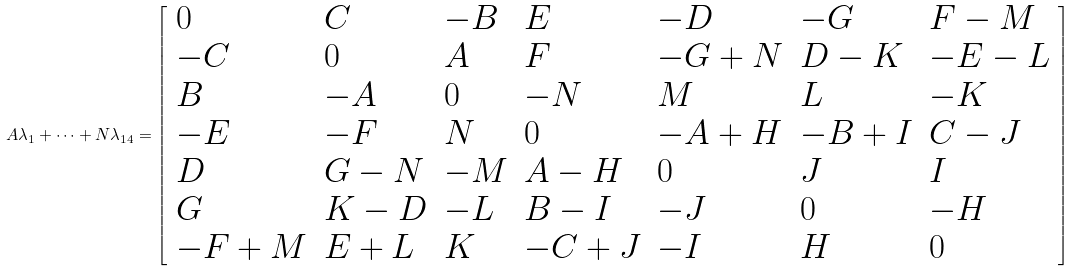<formula> <loc_0><loc_0><loc_500><loc_500>A \lambda _ { 1 } + \cdots + N \lambda _ { 1 4 } = { \left [ \begin{array} { l l l l l l l } { 0 } & { C } & { - B } & { E } & { - D } & { - G } & { F - M } \\ { - C } & { 0 } & { A } & { F } & { - G + N } & { D - K } & { - E - L } \\ { B } & { - A } & { 0 } & { - N } & { M } & { L } & { - K } \\ { - E } & { - F } & { N } & { 0 } & { - A + H } & { - B + I } & { C - J } \\ { D } & { G - N } & { - M } & { A - H } & { 0 } & { J } & { I } \\ { G } & { K - D } & { - L } & { B - I } & { - J } & { 0 } & { - H } \\ { - F + M } & { E + L } & { K } & { - C + J } & { - I } & { H } & { 0 } \end{array} \right ] }</formula> 